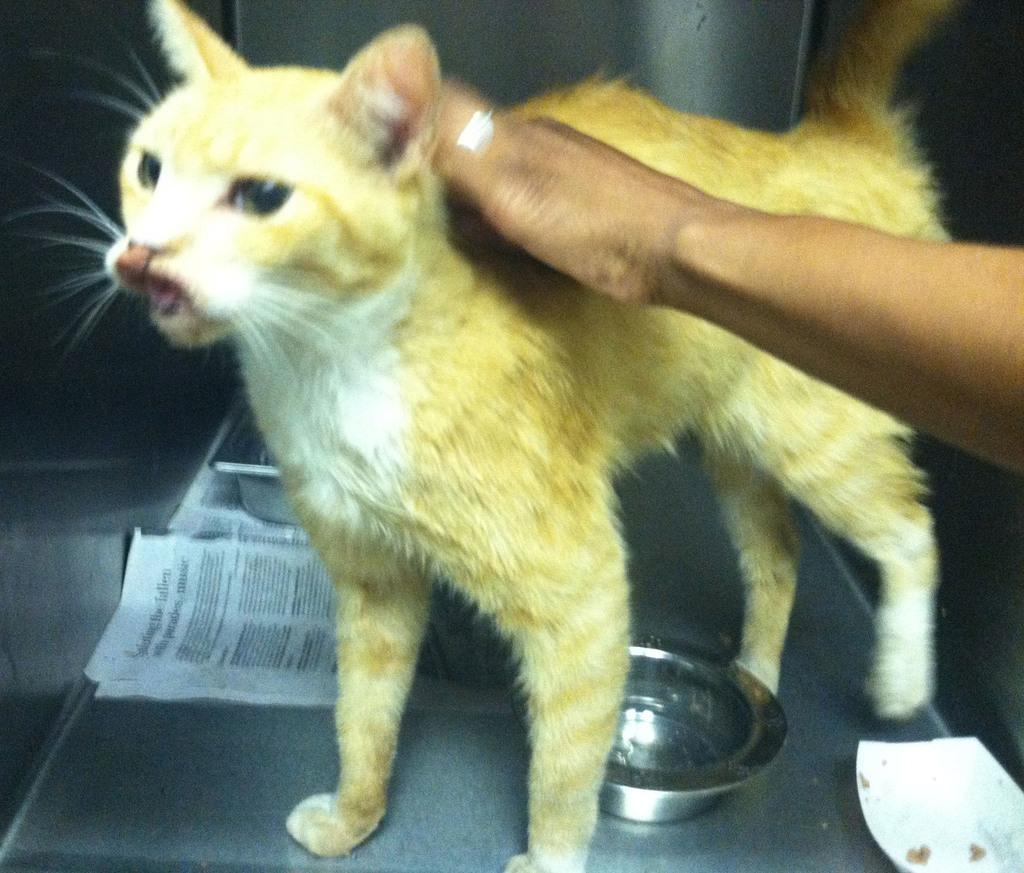What animal is on the table in the image? There is a cat on the table in the image. What else is on the table besides the cat? There is a newspaper and bowls on the table. Can you describe the interaction between the person and the cat? A person's hand is on the cat in the image. What type of drum is being played by the cat in the image? There is no drum present in the image, and the cat is not playing any instrument. 